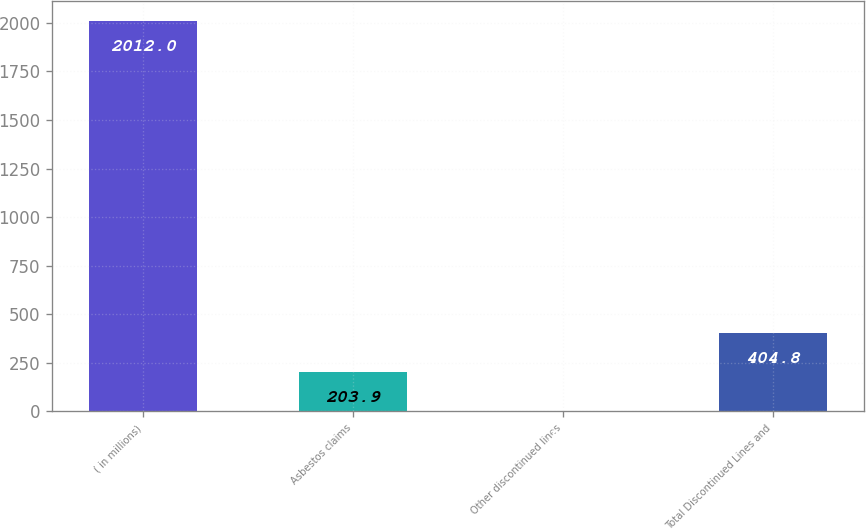Convert chart to OTSL. <chart><loc_0><loc_0><loc_500><loc_500><bar_chart><fcel>( in millions)<fcel>Asbestos claims<fcel>Other discontinued lines<fcel>Total Discontinued Lines and<nl><fcel>2012<fcel>203.9<fcel>3<fcel>404.8<nl></chart> 